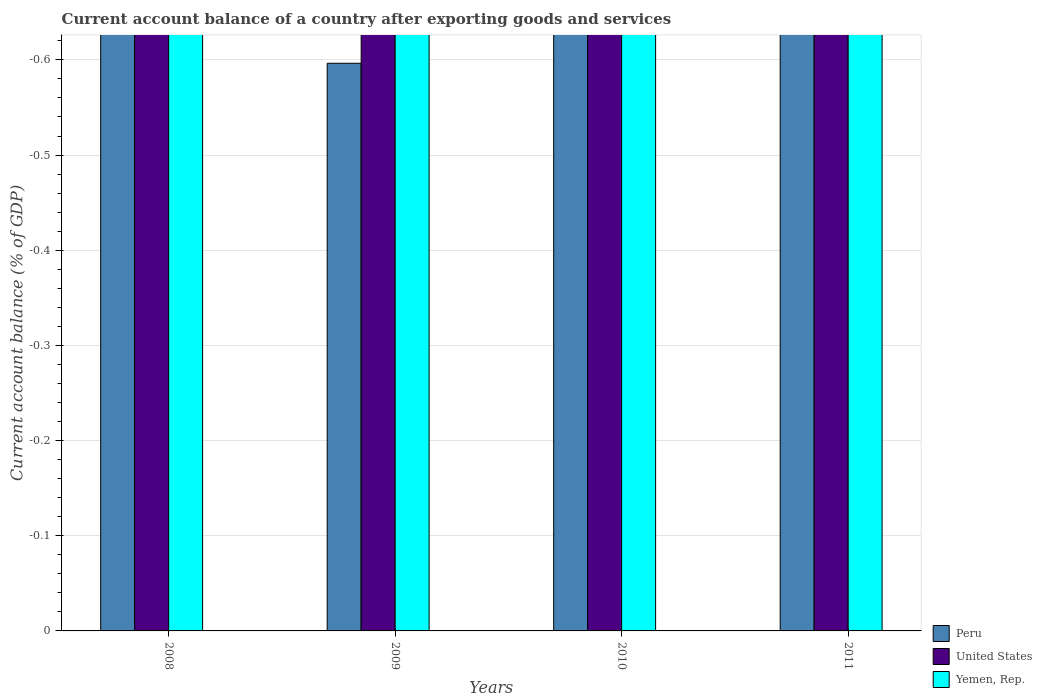How many different coloured bars are there?
Provide a short and direct response. 0. Are the number of bars on each tick of the X-axis equal?
Your answer should be compact. Yes. How many bars are there on the 3rd tick from the left?
Make the answer very short. 0. How many bars are there on the 3rd tick from the right?
Offer a very short reply. 0. In how many cases, is the number of bars for a given year not equal to the number of legend labels?
Your answer should be very brief. 4. What is the difference between the account balance in Yemen, Rep. in 2010 and the account balance in Peru in 2009?
Ensure brevity in your answer.  0. In how many years, is the account balance in United States greater than -0.12000000000000001 %?
Your answer should be compact. 0. Are all the bars in the graph horizontal?
Your answer should be compact. No. What is the difference between two consecutive major ticks on the Y-axis?
Ensure brevity in your answer.  0.1. Are the values on the major ticks of Y-axis written in scientific E-notation?
Your answer should be compact. No. Where does the legend appear in the graph?
Provide a short and direct response. Bottom right. How many legend labels are there?
Make the answer very short. 3. What is the title of the graph?
Offer a terse response. Current account balance of a country after exporting goods and services. Does "Fragile and conflict affected situations" appear as one of the legend labels in the graph?
Your answer should be compact. No. What is the label or title of the Y-axis?
Offer a terse response. Current account balance (% of GDP). What is the Current account balance (% of GDP) in Peru in 2008?
Your response must be concise. 0. What is the Current account balance (% of GDP) of United States in 2008?
Make the answer very short. 0. What is the Current account balance (% of GDP) in Peru in 2009?
Make the answer very short. 0. What is the Current account balance (% of GDP) of United States in 2009?
Your response must be concise. 0. What is the Current account balance (% of GDP) in Yemen, Rep. in 2009?
Offer a very short reply. 0. What is the Current account balance (% of GDP) in Peru in 2011?
Provide a succinct answer. 0. What is the Current account balance (% of GDP) in United States in 2011?
Your answer should be compact. 0. What is the total Current account balance (% of GDP) in Peru in the graph?
Ensure brevity in your answer.  0. What is the total Current account balance (% of GDP) in United States in the graph?
Keep it short and to the point. 0. What is the average Current account balance (% of GDP) in United States per year?
Your response must be concise. 0. 